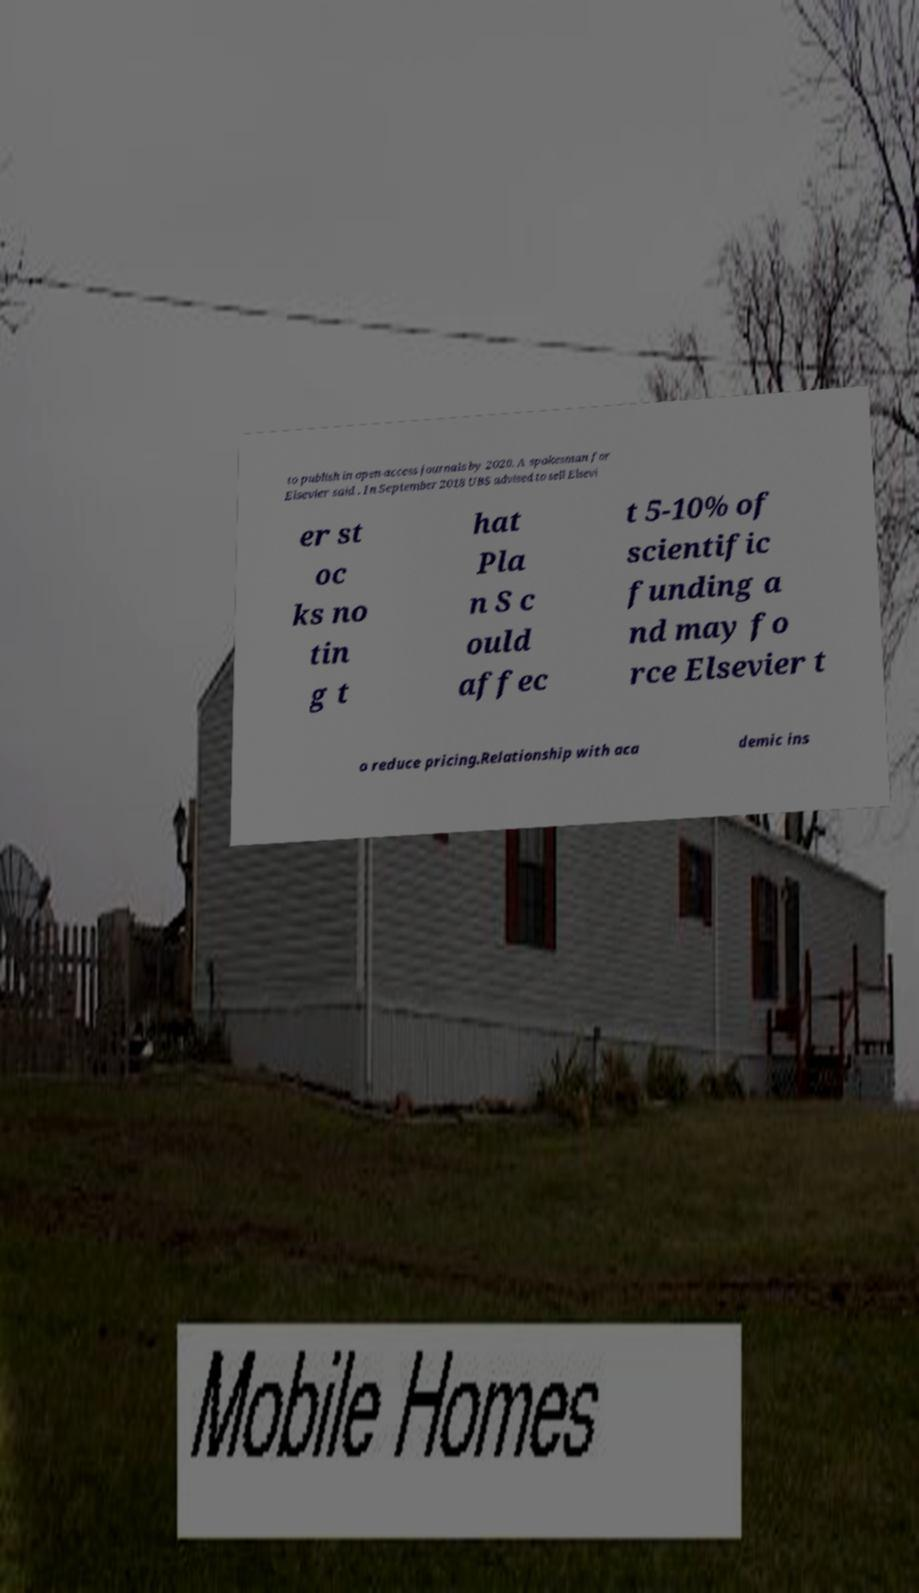There's text embedded in this image that I need extracted. Can you transcribe it verbatim? to publish in open-access journals by 2020. A spokesman for Elsevier said . In September 2018 UBS advised to sell Elsevi er st oc ks no tin g t hat Pla n S c ould affec t 5-10% of scientific funding a nd may fo rce Elsevier t o reduce pricing.Relationship with aca demic ins 